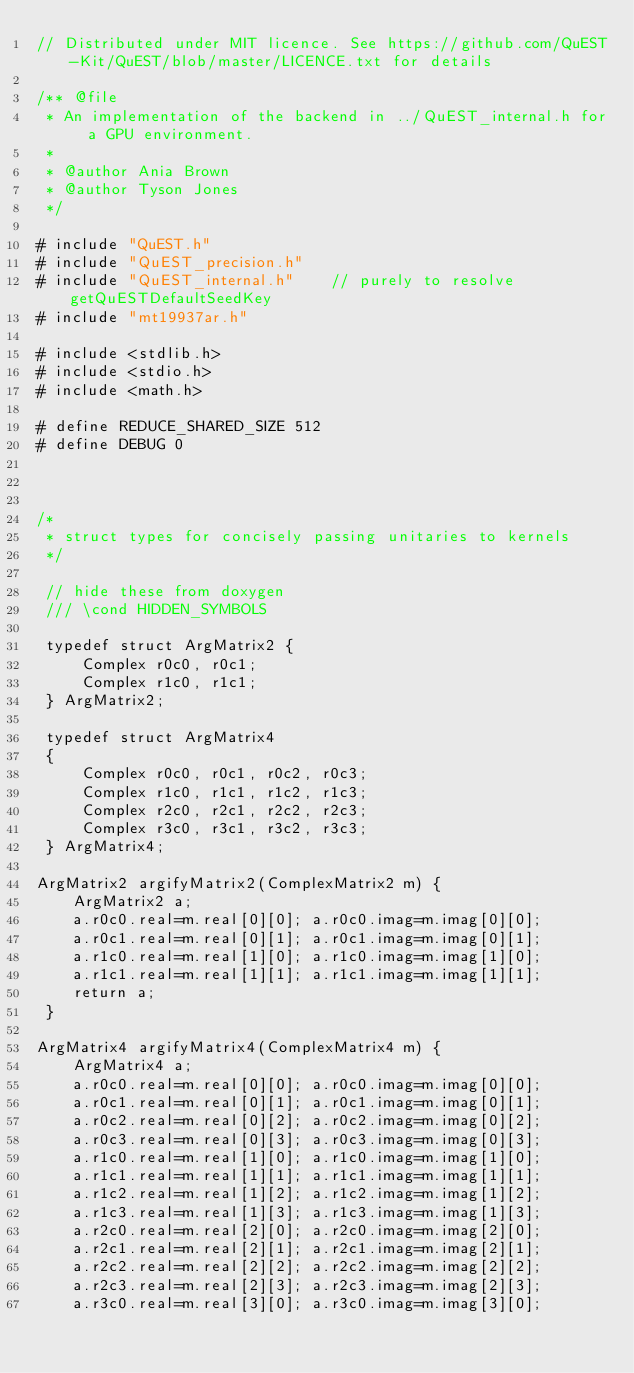<code> <loc_0><loc_0><loc_500><loc_500><_Cuda_>// Distributed under MIT licence. See https://github.com/QuEST-Kit/QuEST/blob/master/LICENCE.txt for details

/** @file
 * An implementation of the backend in ../QuEST_internal.h for a GPU environment.
 *
 * @author Ania Brown 
 * @author Tyson Jones
 */

# include "QuEST.h"
# include "QuEST_precision.h"
# include "QuEST_internal.h"    // purely to resolve getQuESTDefaultSeedKey
# include "mt19937ar.h"

# include <stdlib.h>
# include <stdio.h>
# include <math.h>

# define REDUCE_SHARED_SIZE 512
# define DEBUG 0



/*
 * struct types for concisely passing unitaries to kernels
 */
 
 // hide these from doxygen
 /// \cond HIDDEN_SYMBOLS  
 
 typedef struct ArgMatrix2 {
     Complex r0c0, r0c1;
     Complex r1c0, r1c1;
 } ArgMatrix2;
 
 typedef struct ArgMatrix4
 {
     Complex r0c0, r0c1, r0c2, r0c3;
     Complex r1c0, r1c1, r1c2, r1c3;
     Complex r2c0, r2c1, r2c2, r2c3;
     Complex r3c0, r3c1, r3c2, r3c3;
 } ArgMatrix4;
 
ArgMatrix2 argifyMatrix2(ComplexMatrix2 m) {    
    ArgMatrix2 a;
    a.r0c0.real=m.real[0][0]; a.r0c0.imag=m.imag[0][0];
    a.r0c1.real=m.real[0][1]; a.r0c1.imag=m.imag[0][1];
    a.r1c0.real=m.real[1][0]; a.r1c0.imag=m.imag[1][0];
    a.r1c1.real=m.real[1][1]; a.r1c1.imag=m.imag[1][1];
    return a;
 }

ArgMatrix4 argifyMatrix4(ComplexMatrix4 m) {     
    ArgMatrix4 a;
    a.r0c0.real=m.real[0][0]; a.r0c0.imag=m.imag[0][0];
    a.r0c1.real=m.real[0][1]; a.r0c1.imag=m.imag[0][1];
    a.r0c2.real=m.real[0][2]; a.r0c2.imag=m.imag[0][2];
    a.r0c3.real=m.real[0][3]; a.r0c3.imag=m.imag[0][3];
    a.r1c0.real=m.real[1][0]; a.r1c0.imag=m.imag[1][0];
    a.r1c1.real=m.real[1][1]; a.r1c1.imag=m.imag[1][1];
    a.r1c2.real=m.real[1][2]; a.r1c2.imag=m.imag[1][2];
    a.r1c3.real=m.real[1][3]; a.r1c3.imag=m.imag[1][3];
    a.r2c0.real=m.real[2][0]; a.r2c0.imag=m.imag[2][0];
    a.r2c1.real=m.real[2][1]; a.r2c1.imag=m.imag[2][1];
    a.r2c2.real=m.real[2][2]; a.r2c2.imag=m.imag[2][2];
    a.r2c3.real=m.real[2][3]; a.r2c3.imag=m.imag[2][3];
    a.r3c0.real=m.real[3][0]; a.r3c0.imag=m.imag[3][0];</code> 